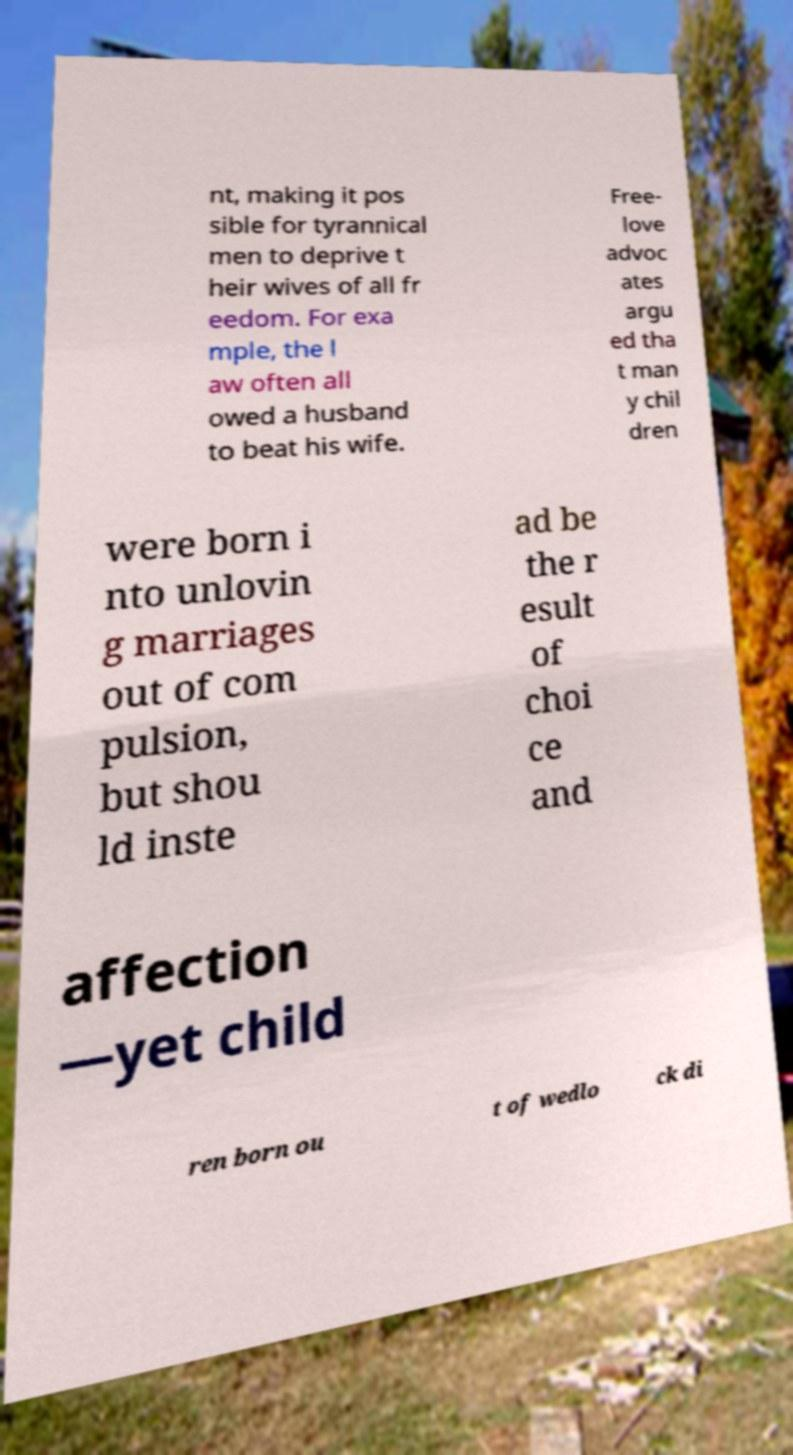Can you read and provide the text displayed in the image?This photo seems to have some interesting text. Can you extract and type it out for me? nt, making it pos sible for tyrannical men to deprive t heir wives of all fr eedom. For exa mple, the l aw often all owed a husband to beat his wife. Free- love advoc ates argu ed tha t man y chil dren were born i nto unlovin g marriages out of com pulsion, but shou ld inste ad be the r esult of choi ce and affection —yet child ren born ou t of wedlo ck di 